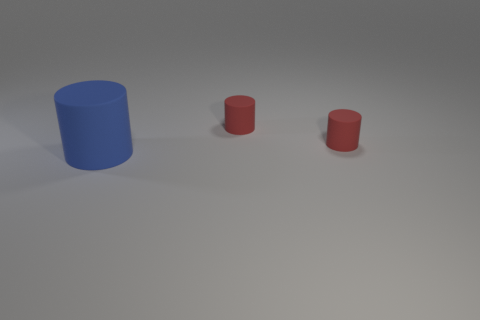What number of small red cylinders are there?
Keep it short and to the point. 2. There is a large rubber object; are there any tiny rubber cylinders behind it?
Make the answer very short. Yes. How many blue objects are either tiny matte things or large objects?
Provide a short and direct response. 1. Is the number of big blue objects left of the big blue matte object the same as the number of big red shiny things?
Provide a succinct answer. Yes. What number of objects are big objects or red matte objects that are behind the blue matte object?
Offer a terse response. 3. Are there any cyan cylinders that have the same material as the blue cylinder?
Provide a short and direct response. No. Are there any large rubber things that have the same color as the large cylinder?
Offer a very short reply. No. How many blue rubber cylinders are right of the blue object?
Provide a succinct answer. 0. What number of other objects are the same size as the blue rubber thing?
Offer a very short reply. 0. Is there any other thing that has the same color as the big cylinder?
Offer a very short reply. No. 